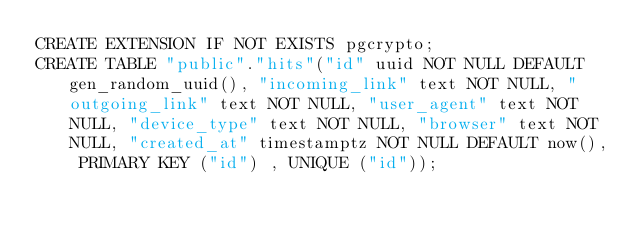<code> <loc_0><loc_0><loc_500><loc_500><_SQL_>CREATE EXTENSION IF NOT EXISTS pgcrypto;
CREATE TABLE "public"."hits"("id" uuid NOT NULL DEFAULT gen_random_uuid(), "incoming_link" text NOT NULL, "outgoing_link" text NOT NULL, "user_agent" text NOT NULL, "device_type" text NOT NULL, "browser" text NOT NULL, "created_at" timestamptz NOT NULL DEFAULT now(), PRIMARY KEY ("id") , UNIQUE ("id"));</code> 